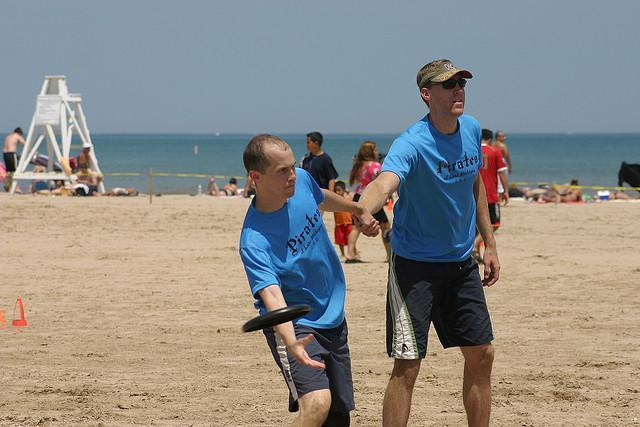How many people are there?
Give a very brief answer. 2. 